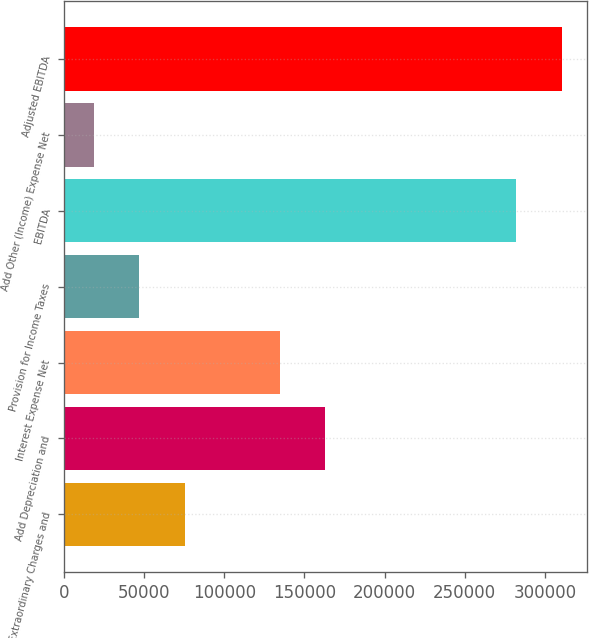<chart> <loc_0><loc_0><loc_500><loc_500><bar_chart><fcel>Extraordinary Charges and<fcel>Add Depreciation and<fcel>Interest Expense Net<fcel>Provision for Income Taxes<fcel>EBITDA<fcel>Add Other (Income) Expense Net<fcel>Adjusted EBITDA<nl><fcel>75146<fcel>163130<fcel>134742<fcel>46758.5<fcel>282131<fcel>18371<fcel>310518<nl></chart> 